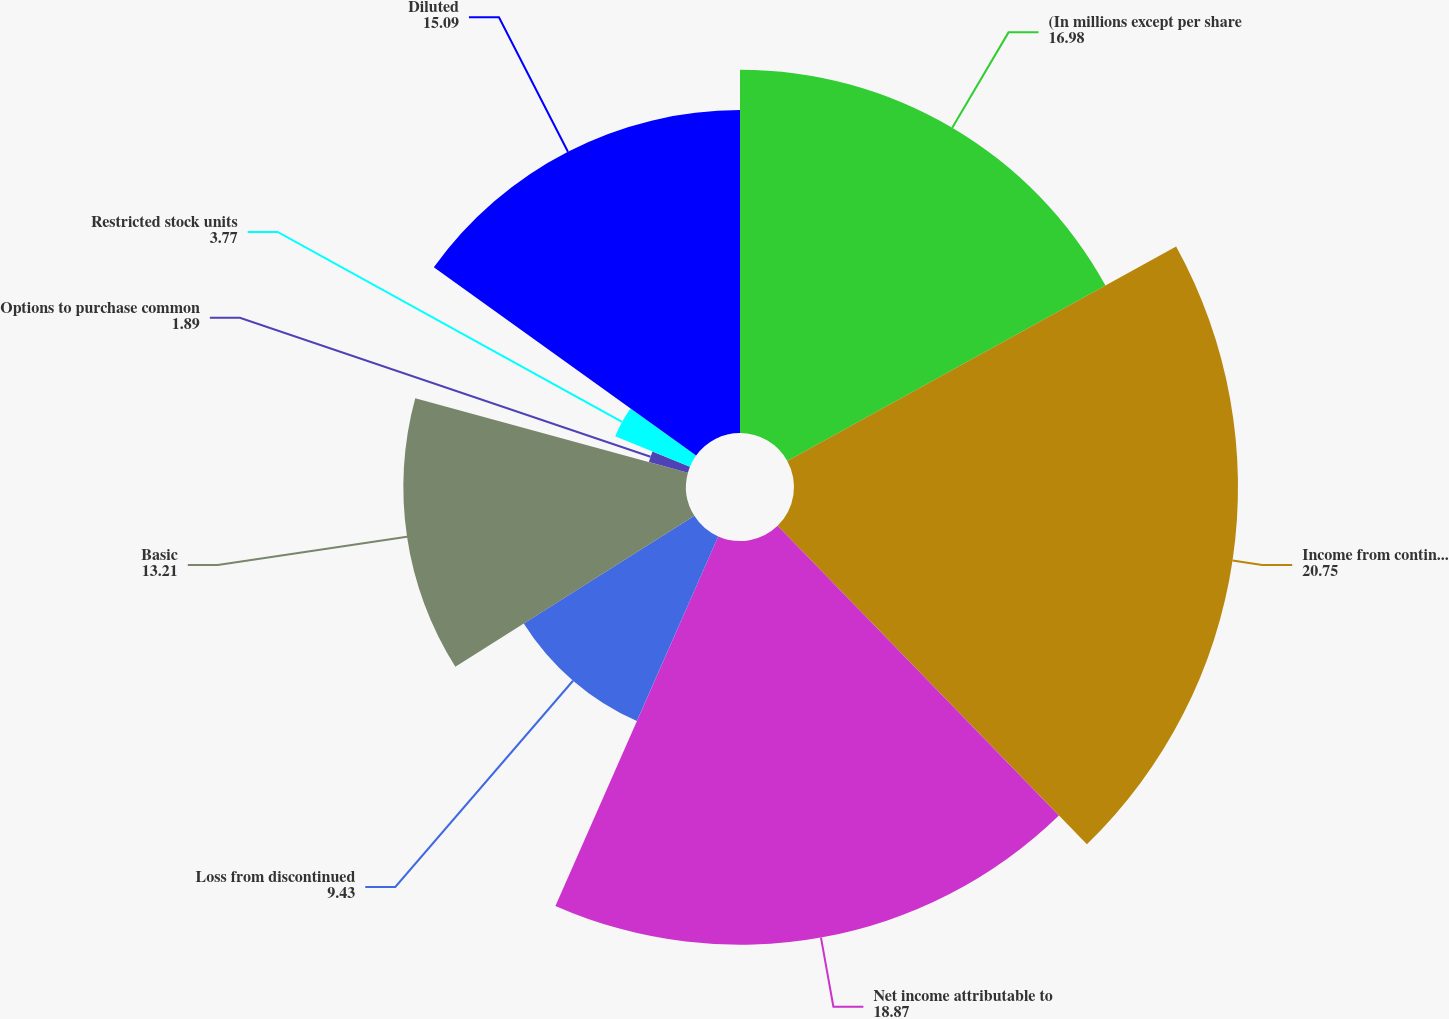Convert chart. <chart><loc_0><loc_0><loc_500><loc_500><pie_chart><fcel>(In millions except per share<fcel>Income from continuing<fcel>Net income attributable to<fcel>Loss from discontinued<fcel>Basic<fcel>Options to purchase common<fcel>Restricted stock units<fcel>Diluted<nl><fcel>16.98%<fcel>20.75%<fcel>18.87%<fcel>9.43%<fcel>13.21%<fcel>1.89%<fcel>3.77%<fcel>15.09%<nl></chart> 